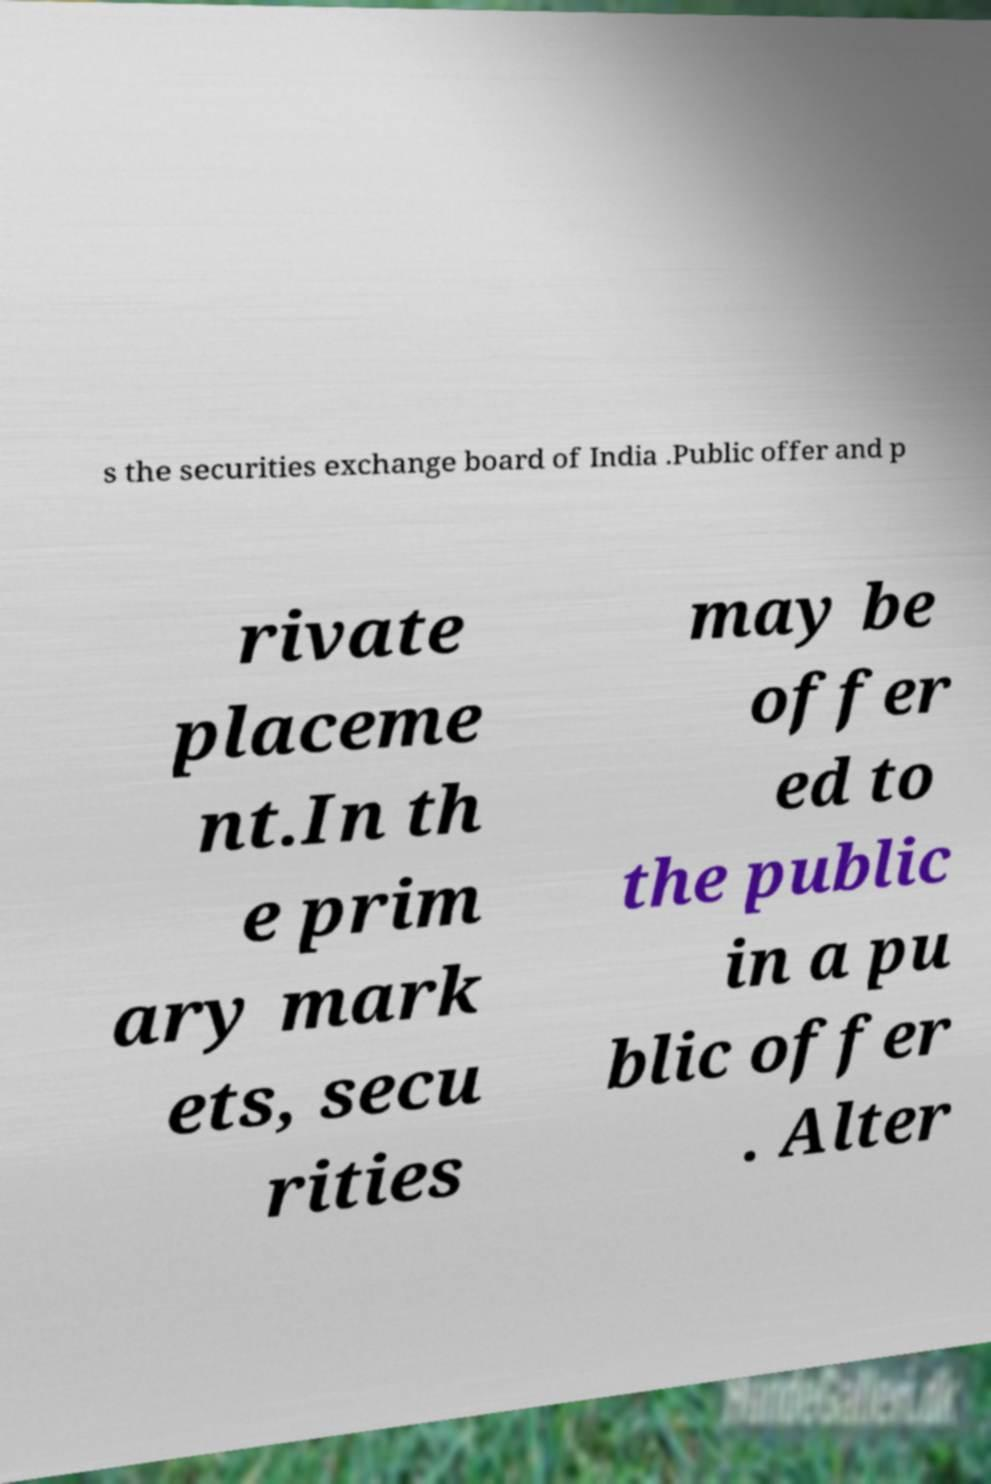I need the written content from this picture converted into text. Can you do that? s the securities exchange board of India .Public offer and p rivate placeme nt.In th e prim ary mark ets, secu rities may be offer ed to the public in a pu blic offer . Alter 